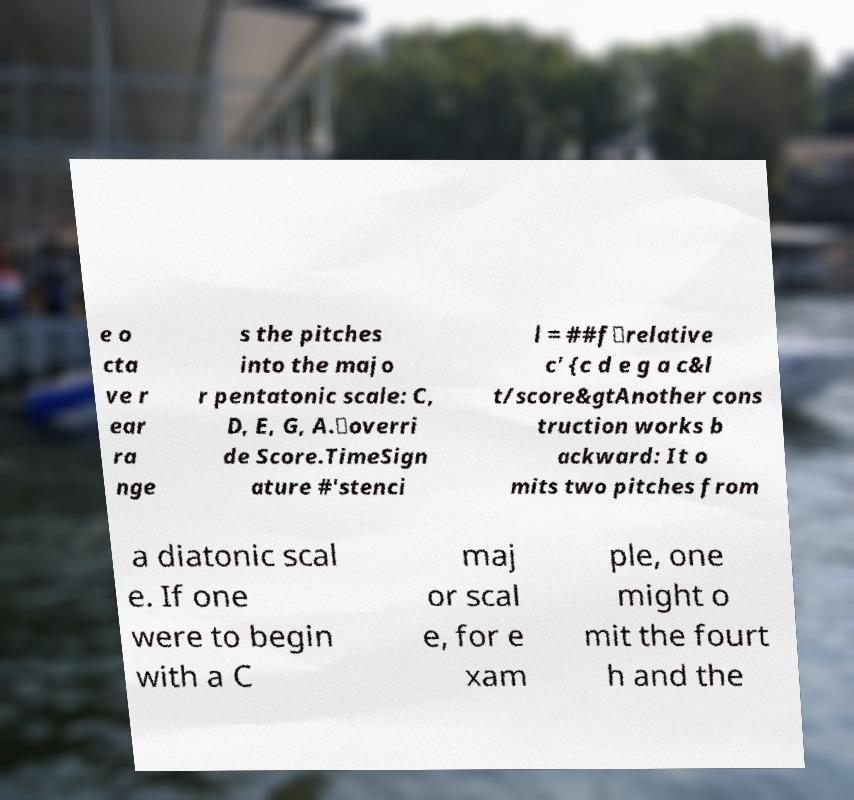Could you assist in decoding the text presented in this image and type it out clearly? e o cta ve r ear ra nge s the pitches into the majo r pentatonic scale: C, D, E, G, A.\overri de Score.TimeSign ature #'stenci l = ##f\relative c' {c d e g a c&l t/score&gtAnother cons truction works b ackward: It o mits two pitches from a diatonic scal e. If one were to begin with a C maj or scal e, for e xam ple, one might o mit the fourt h and the 